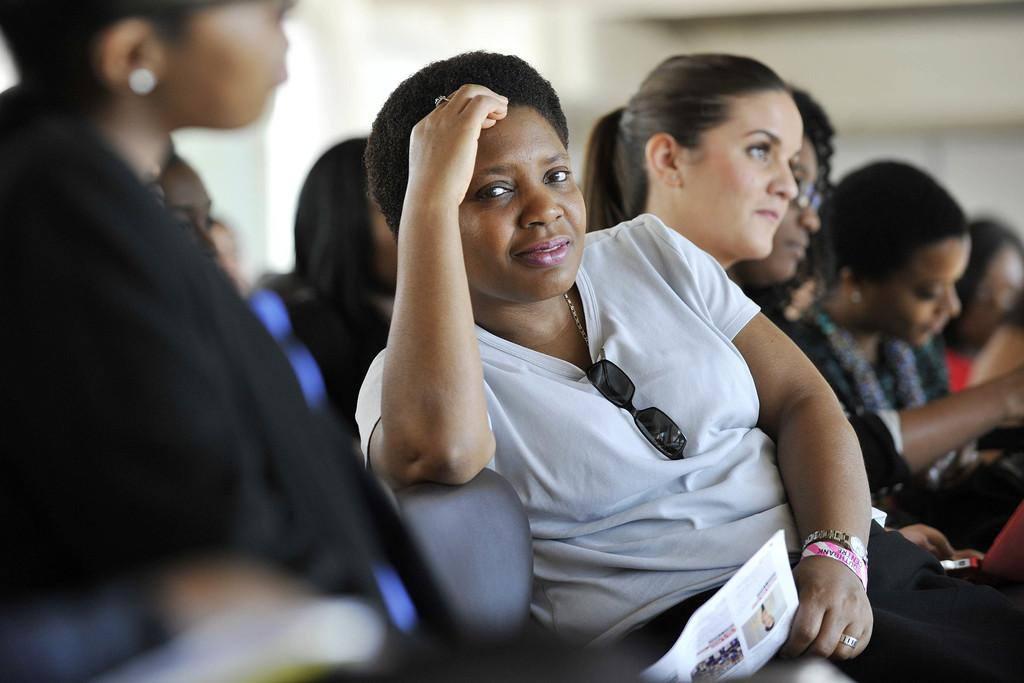How many people are the persons are in the image? There is a group of persons in the image. What are the persons in the image doing? The persons are sitting on chairs. Can you describe the person sitting in the middle of the group? The person in the middle is wearing a white t-shirt and is holding a paper. What type of kettle is visible in the image? There is no kettle present in the image. Can you describe the monkey sitting on the person's shoulder in the image? There is no monkey present in the image. 